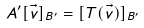<formula> <loc_0><loc_0><loc_500><loc_500>A ^ { \prime } [ \vec { v } ] _ { B ^ { \prime } } = [ T ( \vec { v } ) ] _ { B ^ { \prime } }</formula> 